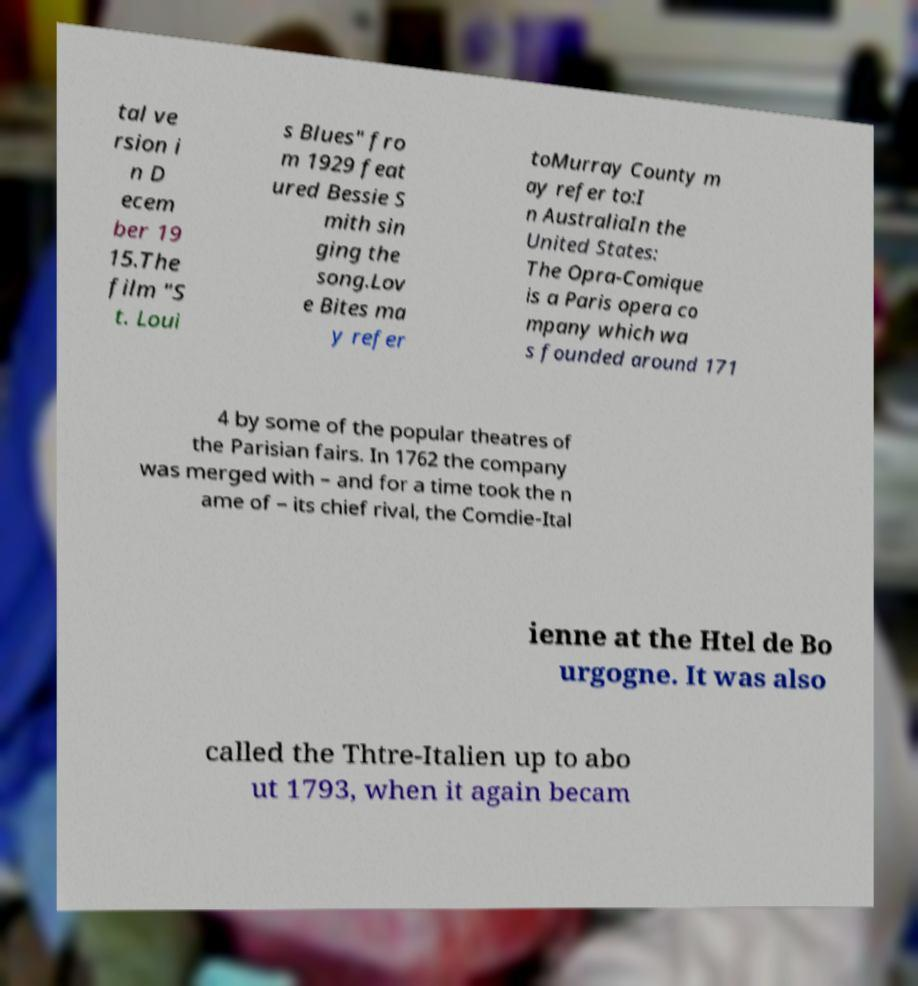Please read and relay the text visible in this image. What does it say? tal ve rsion i n D ecem ber 19 15.The film "S t. Loui s Blues" fro m 1929 feat ured Bessie S mith sin ging the song.Lov e Bites ma y refer toMurray County m ay refer to:I n AustraliaIn the United States: The Opra-Comique is a Paris opera co mpany which wa s founded around 171 4 by some of the popular theatres of the Parisian fairs. In 1762 the company was merged with – and for a time took the n ame of – its chief rival, the Comdie-Ital ienne at the Htel de Bo urgogne. It was also called the Thtre-Italien up to abo ut 1793, when it again becam 